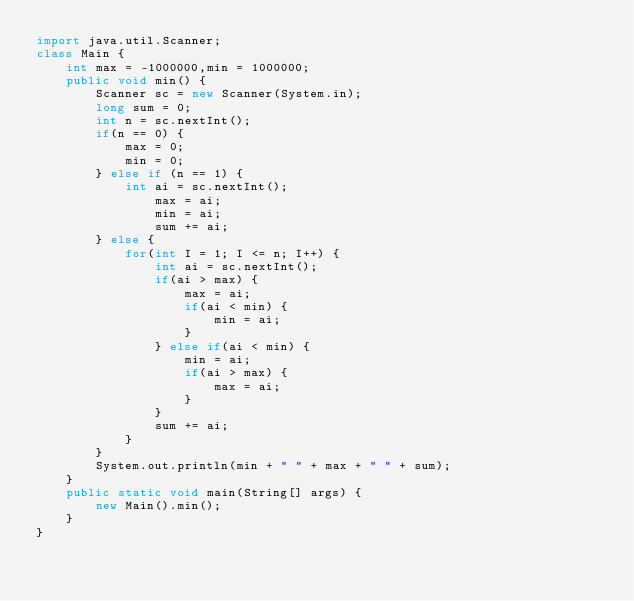Convert code to text. <code><loc_0><loc_0><loc_500><loc_500><_Java_>import java.util.Scanner;
class Main {
	int max = -1000000,min = 1000000;
	public void min() {
		Scanner sc = new Scanner(System.in);
		long sum = 0;
		int n = sc.nextInt();
		if(n == 0) {
			max = 0;
			min = 0;
		} else if (n == 1) {
			int ai = sc.nextInt();
				max = ai;
				min = ai;
				sum += ai;
		} else {
			for(int I = 1; I <= n; I++) {
				int ai = sc.nextInt();
				if(ai > max) {
					max = ai;
					if(ai < min) {
						min = ai;
					}
				} else if(ai < min) {
					min = ai;
					if(ai > max) {
						max = ai;
					}
				}
				sum += ai;
			}
		}
		System.out.println(min + " " + max + " " + sum);
	}
	public static void main(String[] args) {
		new Main().min();
	}
}</code> 